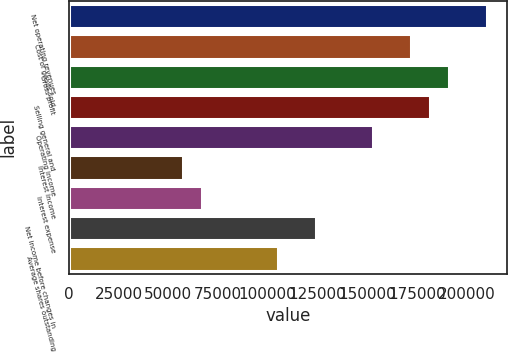Convert chart. <chart><loc_0><loc_0><loc_500><loc_500><bar_chart><fcel>Net operating revenues<fcel>Cost of goods sold<fcel>Gross profit<fcel>Selling general and<fcel>Operating income<fcel>Interest income<fcel>Interest expense<fcel>Net income before changes in<fcel>Average shares outstanding<nl><fcel>210108<fcel>171906<fcel>191007<fcel>181457<fcel>152806<fcel>57302.9<fcel>66853.1<fcel>124155<fcel>105054<nl></chart> 